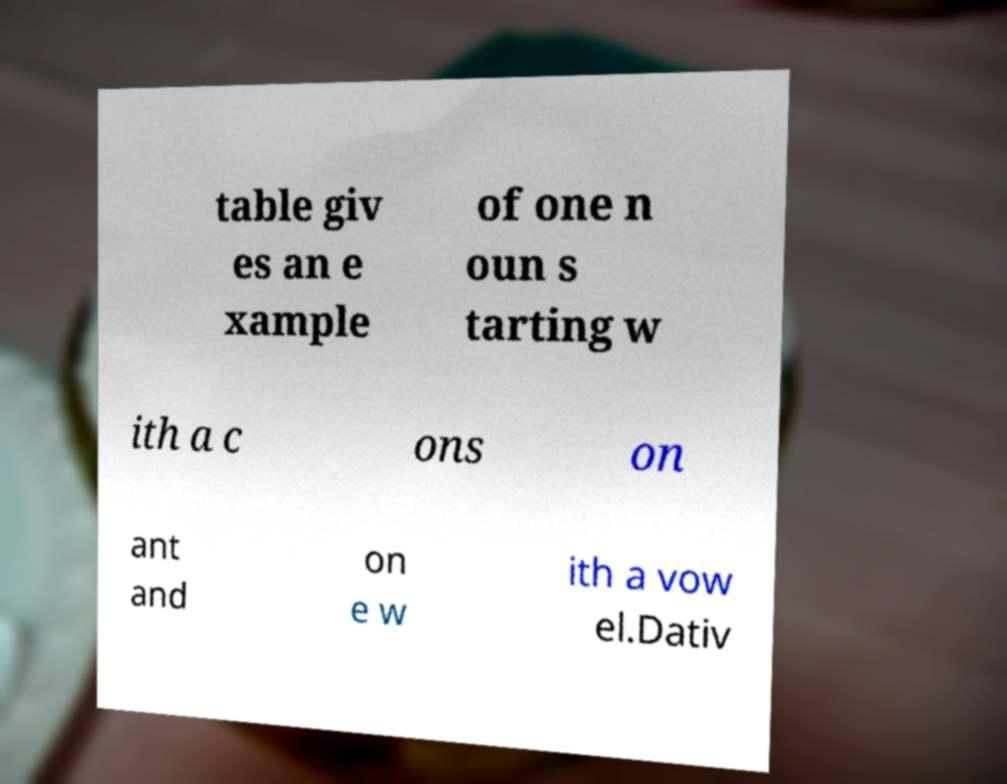I need the written content from this picture converted into text. Can you do that? table giv es an e xample of one n oun s tarting w ith a c ons on ant and on e w ith a vow el.Dativ 